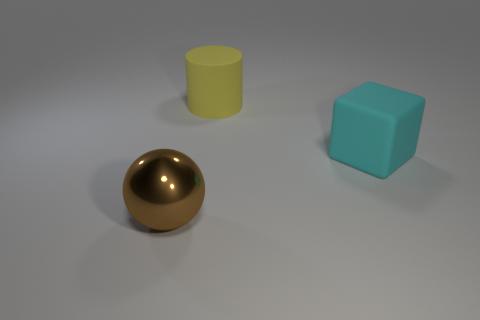Add 1 large green metallic balls. How many objects exist? 4 Subtract all yellow cylinders. How many red blocks are left? 0 Subtract all large balls. Subtract all rubber cylinders. How many objects are left? 1 Add 3 yellow objects. How many yellow objects are left? 4 Add 2 big green cylinders. How many big green cylinders exist? 2 Subtract 0 red cylinders. How many objects are left? 3 Subtract all blocks. How many objects are left? 2 Subtract 1 cylinders. How many cylinders are left? 0 